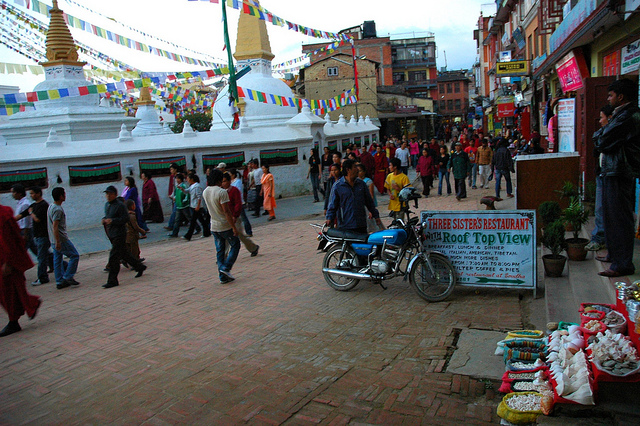<image>What kind of banners and flags are being held up? It is unknown what kind of banners or flags are being held up. They could be colorful, decorative, festive or multicolored. What kind of banners and flags are being held up? I don't know what kind of banners and flags are being held up. It can be colorful, streamers, or decorative. 